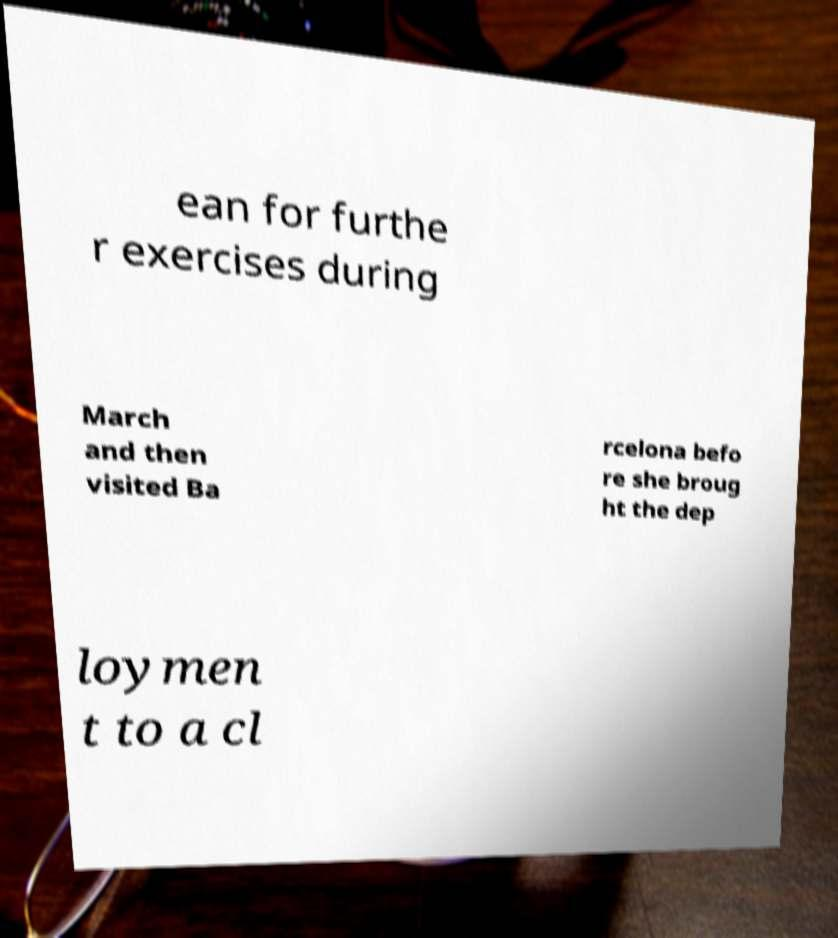Can you accurately transcribe the text from the provided image for me? ean for furthe r exercises during March and then visited Ba rcelona befo re she broug ht the dep loymen t to a cl 